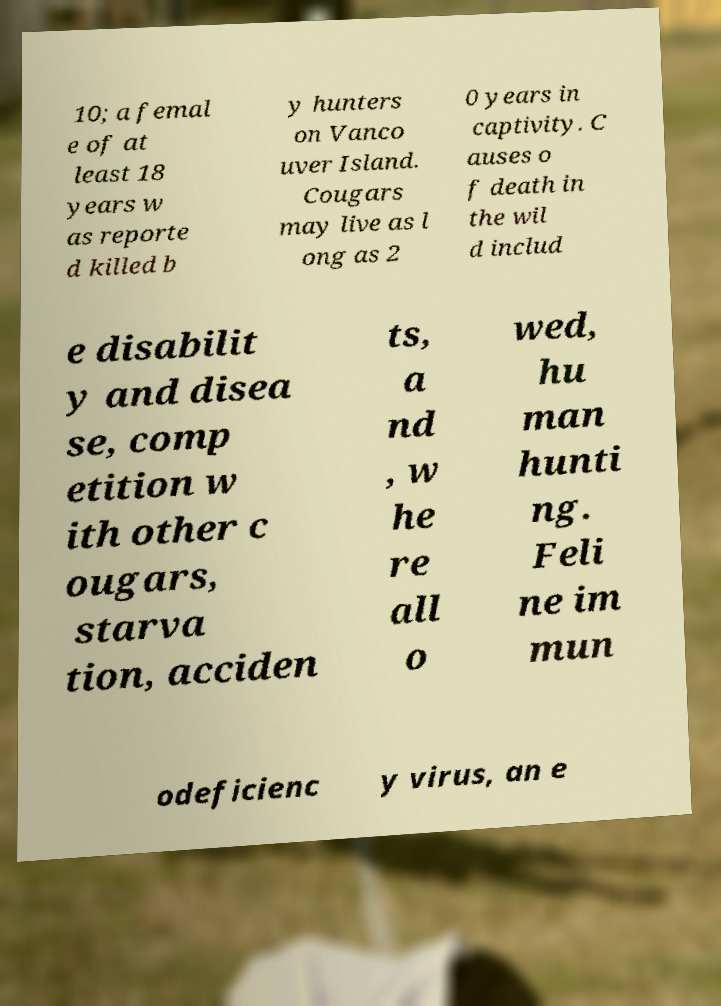Could you assist in decoding the text presented in this image and type it out clearly? 10; a femal e of at least 18 years w as reporte d killed b y hunters on Vanco uver Island. Cougars may live as l ong as 2 0 years in captivity. C auses o f death in the wil d includ e disabilit y and disea se, comp etition w ith other c ougars, starva tion, acciden ts, a nd , w he re all o wed, hu man hunti ng. Feli ne im mun odeficienc y virus, an e 